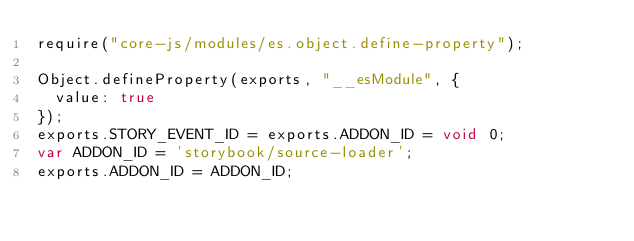<code> <loc_0><loc_0><loc_500><loc_500><_JavaScript_>require("core-js/modules/es.object.define-property");

Object.defineProperty(exports, "__esModule", {
  value: true
});
exports.STORY_EVENT_ID = exports.ADDON_ID = void 0;
var ADDON_ID = 'storybook/source-loader';
exports.ADDON_ID = ADDON_ID;</code> 